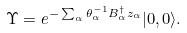<formula> <loc_0><loc_0><loc_500><loc_500>\Upsilon = e ^ { - \sum _ { \alpha } \theta _ { \alpha } ^ { - 1 } B _ { \alpha } ^ { \dag } z _ { \alpha } } | 0 , 0 \rangle .</formula> 